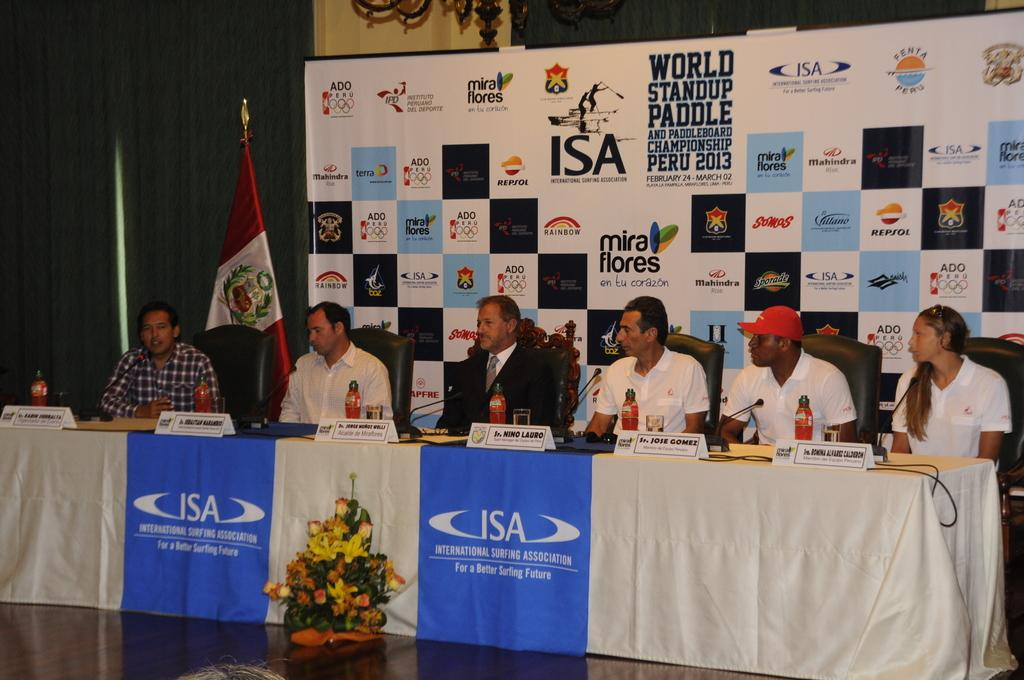What are the people in the image doing? People are sitting on chairs near a table in the image. What can be seen above the table? There is a bottle above the table. What is visible in the background of the image? There is a poster and a flag in the background. What advice is the fish in the image giving to the people sitting near the table? There is no fish present in the image, so it cannot provide any advice. 